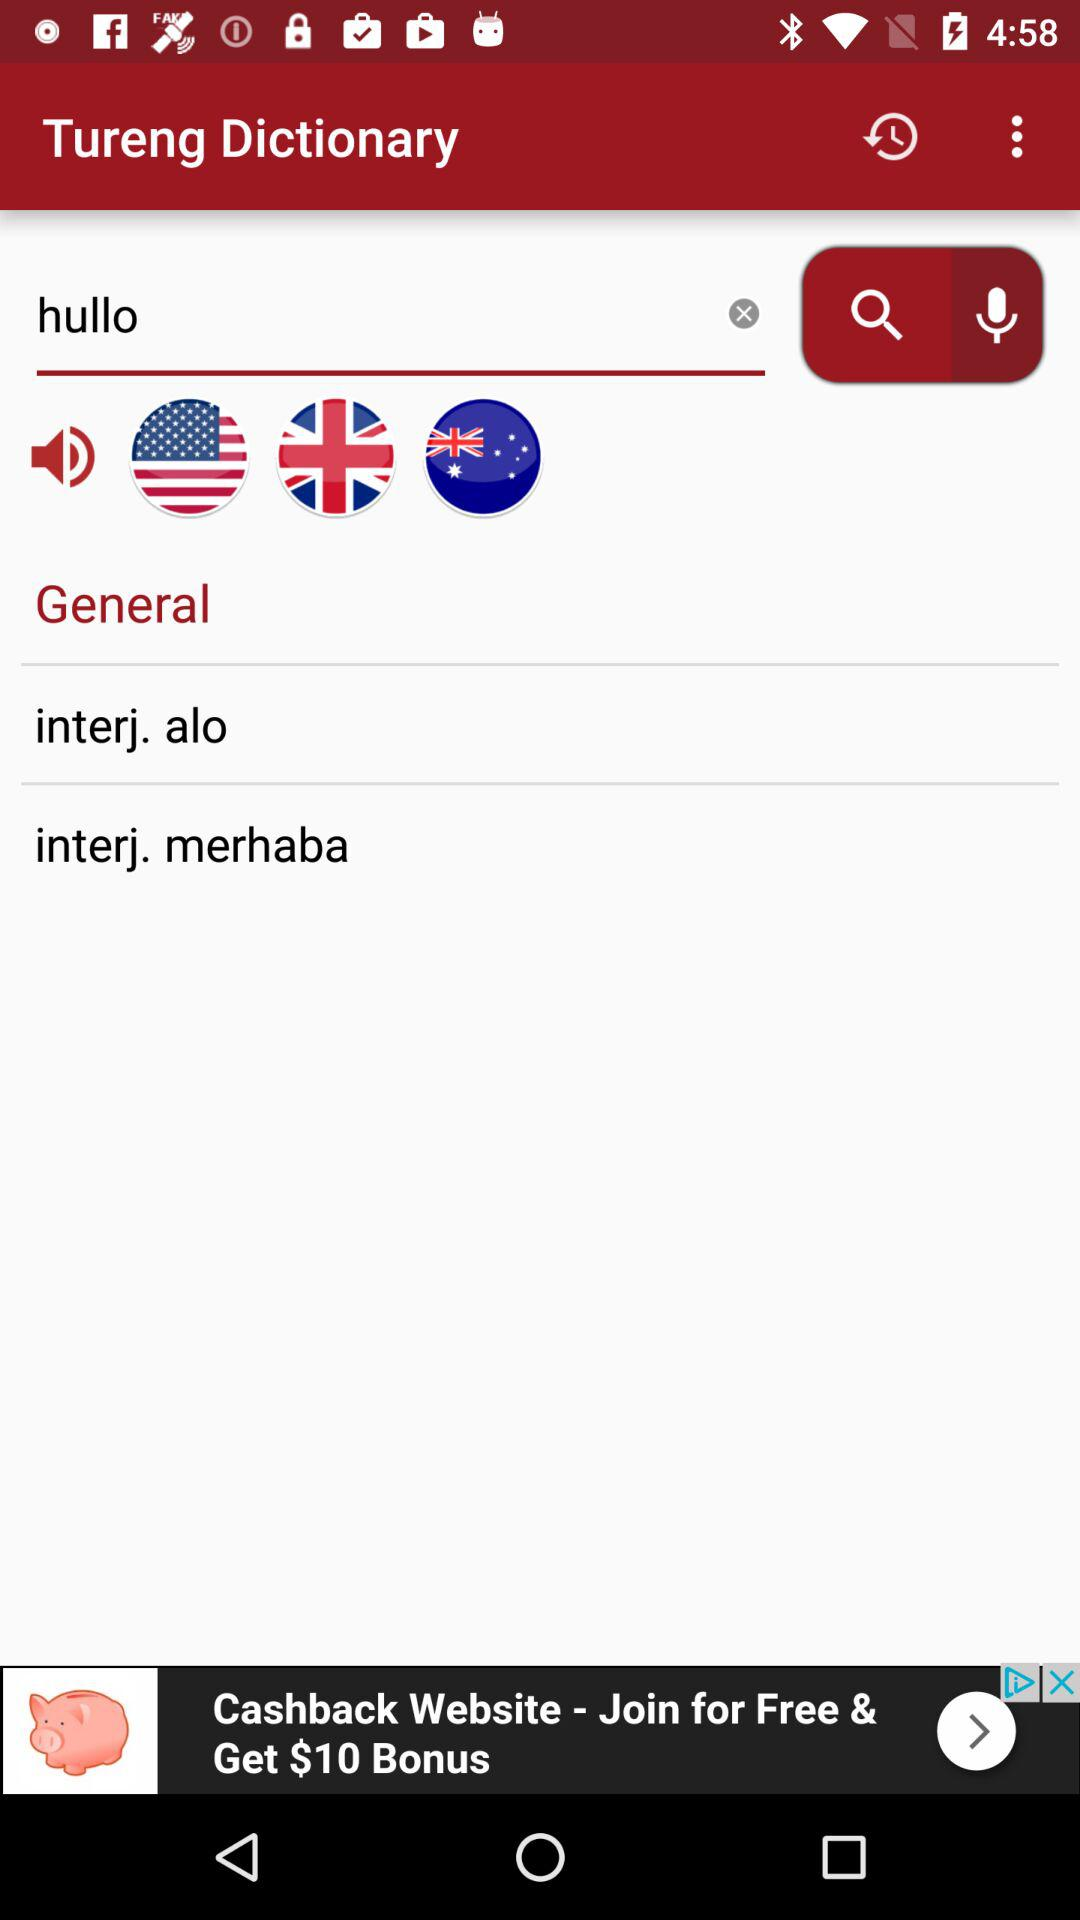What is the application name? The application name is "Tureng Dictionary". 